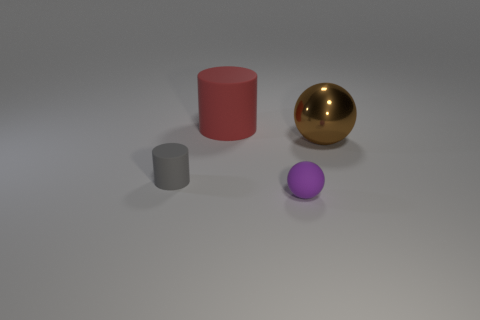Add 2 blue things. How many objects exist? 6 Subtract all brown spheres. How many spheres are left? 1 Subtract all yellow spheres. How many green cylinders are left? 0 Add 4 brown balls. How many brown balls are left? 5 Add 3 small brown metallic objects. How many small brown metallic objects exist? 3 Subtract 0 green blocks. How many objects are left? 4 Subtract 2 cylinders. How many cylinders are left? 0 Subtract all green cylinders. Subtract all blue spheres. How many cylinders are left? 2 Subtract all large objects. Subtract all tiny purple matte cubes. How many objects are left? 2 